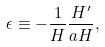<formula> <loc_0><loc_0><loc_500><loc_500>\epsilon \equiv - \frac { 1 } { H } \frac { H ^ { \prime } } { a H } ,</formula> 